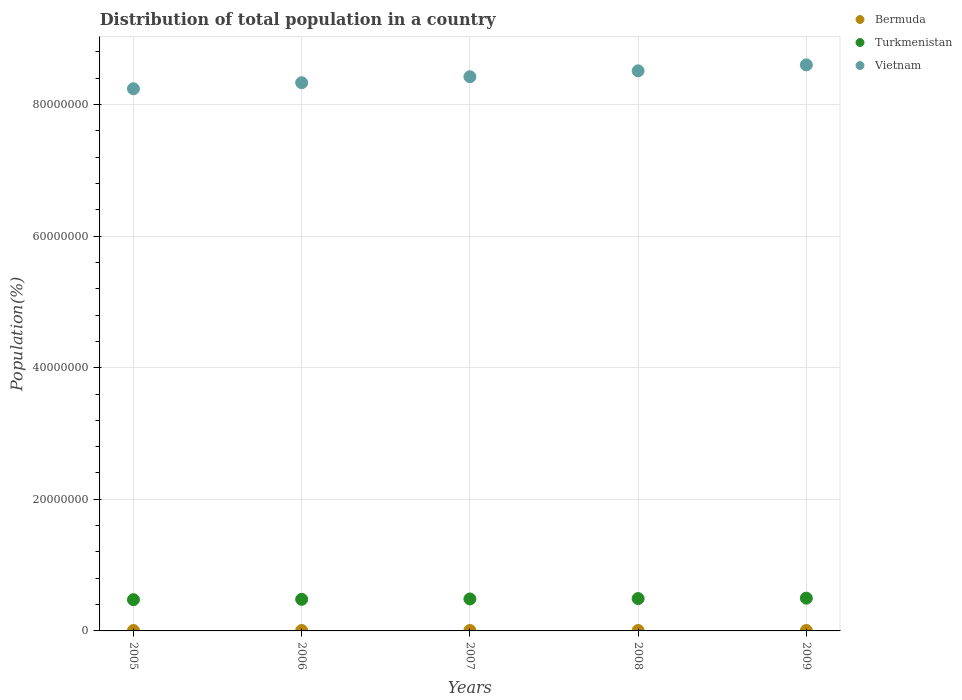What is the population of in Turkmenistan in 2008?
Your answer should be very brief. 4.92e+06. Across all years, what is the maximum population of in Vietnam?
Your answer should be very brief. 8.60e+07. Across all years, what is the minimum population of in Turkmenistan?
Ensure brevity in your answer.  4.75e+06. What is the total population of in Bermuda in the graph?
Your answer should be very brief. 3.24e+05. What is the difference between the population of in Turkmenistan in 2005 and that in 2006?
Your answer should be very brief. -5.38e+04. What is the difference between the population of in Vietnam in 2005 and the population of in Bermuda in 2009?
Provide a short and direct response. 8.23e+07. What is the average population of in Turkmenistan per year?
Make the answer very short. 4.86e+06. In the year 2008, what is the difference between the population of in Vietnam and population of in Bermuda?
Your answer should be compact. 8.51e+07. In how many years, is the population of in Bermuda greater than 80000000 %?
Provide a short and direct response. 0. What is the ratio of the population of in Turkmenistan in 2005 to that in 2006?
Offer a very short reply. 0.99. What is the difference between the highest and the second highest population of in Bermuda?
Provide a succinct answer. 363. What is the difference between the highest and the lowest population of in Bermuda?
Give a very brief answer. 1482. Is the sum of the population of in Bermuda in 2006 and 2009 greater than the maximum population of in Turkmenistan across all years?
Make the answer very short. No. Is it the case that in every year, the sum of the population of in Bermuda and population of in Turkmenistan  is greater than the population of in Vietnam?
Offer a terse response. No. Does the population of in Bermuda monotonically increase over the years?
Keep it short and to the point. Yes. Is the population of in Vietnam strictly less than the population of in Bermuda over the years?
Keep it short and to the point. No. How many years are there in the graph?
Your response must be concise. 5. Where does the legend appear in the graph?
Make the answer very short. Top right. How many legend labels are there?
Provide a succinct answer. 3. What is the title of the graph?
Provide a short and direct response. Distribution of total population in a country. What is the label or title of the Y-axis?
Your response must be concise. Population(%). What is the Population(%) of Bermuda in 2005?
Your response must be concise. 6.42e+04. What is the Population(%) in Turkmenistan in 2005?
Offer a very short reply. 4.75e+06. What is the Population(%) in Vietnam in 2005?
Offer a terse response. 8.24e+07. What is the Population(%) of Bermuda in 2006?
Give a very brief answer. 6.45e+04. What is the Population(%) of Turkmenistan in 2006?
Offer a terse response. 4.80e+06. What is the Population(%) of Vietnam in 2006?
Ensure brevity in your answer.  8.33e+07. What is the Population(%) in Bermuda in 2007?
Your answer should be compact. 6.49e+04. What is the Population(%) of Turkmenistan in 2007?
Your response must be concise. 4.86e+06. What is the Population(%) of Vietnam in 2007?
Make the answer very short. 8.42e+07. What is the Population(%) in Bermuda in 2008?
Offer a very short reply. 6.53e+04. What is the Population(%) of Turkmenistan in 2008?
Keep it short and to the point. 4.92e+06. What is the Population(%) of Vietnam in 2008?
Ensure brevity in your answer.  8.51e+07. What is the Population(%) of Bermuda in 2009?
Offer a very short reply. 6.56e+04. What is the Population(%) of Turkmenistan in 2009?
Your answer should be compact. 4.98e+06. What is the Population(%) of Vietnam in 2009?
Offer a terse response. 8.60e+07. Across all years, what is the maximum Population(%) of Bermuda?
Keep it short and to the point. 6.56e+04. Across all years, what is the maximum Population(%) of Turkmenistan?
Offer a terse response. 4.98e+06. Across all years, what is the maximum Population(%) of Vietnam?
Provide a short and direct response. 8.60e+07. Across all years, what is the minimum Population(%) of Bermuda?
Make the answer very short. 6.42e+04. Across all years, what is the minimum Population(%) of Turkmenistan?
Keep it short and to the point. 4.75e+06. Across all years, what is the minimum Population(%) of Vietnam?
Keep it short and to the point. 8.24e+07. What is the total Population(%) in Bermuda in the graph?
Your answer should be very brief. 3.24e+05. What is the total Population(%) in Turkmenistan in the graph?
Your response must be concise. 2.43e+07. What is the total Population(%) of Vietnam in the graph?
Give a very brief answer. 4.21e+08. What is the difference between the Population(%) of Bermuda in 2005 and that in 2006?
Keep it short and to the point. -369. What is the difference between the Population(%) in Turkmenistan in 2005 and that in 2006?
Make the answer very short. -5.38e+04. What is the difference between the Population(%) of Vietnam in 2005 and that in 2006?
Offer a very short reply. -9.19e+05. What is the difference between the Population(%) in Bermuda in 2005 and that in 2007?
Ensure brevity in your answer.  -734. What is the difference between the Population(%) in Turkmenistan in 2005 and that in 2007?
Offer a terse response. -1.10e+05. What is the difference between the Population(%) of Vietnam in 2005 and that in 2007?
Ensure brevity in your answer.  -1.83e+06. What is the difference between the Population(%) of Bermuda in 2005 and that in 2008?
Offer a terse response. -1119. What is the difference between the Population(%) in Turkmenistan in 2005 and that in 2008?
Your answer should be very brief. -1.70e+05. What is the difference between the Population(%) of Vietnam in 2005 and that in 2008?
Offer a terse response. -2.73e+06. What is the difference between the Population(%) in Bermuda in 2005 and that in 2009?
Make the answer very short. -1482. What is the difference between the Population(%) of Turkmenistan in 2005 and that in 2009?
Keep it short and to the point. -2.31e+05. What is the difference between the Population(%) in Vietnam in 2005 and that in 2009?
Ensure brevity in your answer.  -3.63e+06. What is the difference between the Population(%) of Bermuda in 2006 and that in 2007?
Make the answer very short. -365. What is the difference between the Population(%) in Turkmenistan in 2006 and that in 2007?
Keep it short and to the point. -5.66e+04. What is the difference between the Population(%) in Vietnam in 2006 and that in 2007?
Offer a terse response. -9.07e+05. What is the difference between the Population(%) in Bermuda in 2006 and that in 2008?
Offer a very short reply. -750. What is the difference between the Population(%) in Turkmenistan in 2006 and that in 2008?
Your answer should be very brief. -1.16e+05. What is the difference between the Population(%) in Vietnam in 2006 and that in 2008?
Ensure brevity in your answer.  -1.81e+06. What is the difference between the Population(%) in Bermuda in 2006 and that in 2009?
Give a very brief answer. -1113. What is the difference between the Population(%) in Turkmenistan in 2006 and that in 2009?
Make the answer very short. -1.77e+05. What is the difference between the Population(%) in Vietnam in 2006 and that in 2009?
Your answer should be very brief. -2.71e+06. What is the difference between the Population(%) of Bermuda in 2007 and that in 2008?
Your response must be concise. -385. What is the difference between the Population(%) in Turkmenistan in 2007 and that in 2008?
Your response must be concise. -5.93e+04. What is the difference between the Population(%) in Vietnam in 2007 and that in 2008?
Offer a very short reply. -9.00e+05. What is the difference between the Population(%) of Bermuda in 2007 and that in 2009?
Keep it short and to the point. -748. What is the difference between the Population(%) in Turkmenistan in 2007 and that in 2009?
Make the answer very short. -1.21e+05. What is the difference between the Population(%) of Vietnam in 2007 and that in 2009?
Your response must be concise. -1.81e+06. What is the difference between the Population(%) in Bermuda in 2008 and that in 2009?
Provide a succinct answer. -363. What is the difference between the Population(%) of Turkmenistan in 2008 and that in 2009?
Your answer should be compact. -6.14e+04. What is the difference between the Population(%) in Vietnam in 2008 and that in 2009?
Your response must be concise. -9.06e+05. What is the difference between the Population(%) of Bermuda in 2005 and the Population(%) of Turkmenistan in 2006?
Offer a very short reply. -4.74e+06. What is the difference between the Population(%) of Bermuda in 2005 and the Population(%) of Vietnam in 2006?
Your answer should be compact. -8.32e+07. What is the difference between the Population(%) in Turkmenistan in 2005 and the Population(%) in Vietnam in 2006?
Make the answer very short. -7.86e+07. What is the difference between the Population(%) of Bermuda in 2005 and the Population(%) of Turkmenistan in 2007?
Give a very brief answer. -4.79e+06. What is the difference between the Population(%) of Bermuda in 2005 and the Population(%) of Vietnam in 2007?
Offer a very short reply. -8.42e+07. What is the difference between the Population(%) in Turkmenistan in 2005 and the Population(%) in Vietnam in 2007?
Make the answer very short. -7.95e+07. What is the difference between the Population(%) of Bermuda in 2005 and the Population(%) of Turkmenistan in 2008?
Offer a terse response. -4.85e+06. What is the difference between the Population(%) of Bermuda in 2005 and the Population(%) of Vietnam in 2008?
Offer a very short reply. -8.51e+07. What is the difference between the Population(%) in Turkmenistan in 2005 and the Population(%) in Vietnam in 2008?
Your answer should be compact. -8.04e+07. What is the difference between the Population(%) of Bermuda in 2005 and the Population(%) of Turkmenistan in 2009?
Ensure brevity in your answer.  -4.91e+06. What is the difference between the Population(%) of Bermuda in 2005 and the Population(%) of Vietnam in 2009?
Offer a very short reply. -8.60e+07. What is the difference between the Population(%) of Turkmenistan in 2005 and the Population(%) of Vietnam in 2009?
Offer a very short reply. -8.13e+07. What is the difference between the Population(%) of Bermuda in 2006 and the Population(%) of Turkmenistan in 2007?
Provide a succinct answer. -4.79e+06. What is the difference between the Population(%) in Bermuda in 2006 and the Population(%) in Vietnam in 2007?
Your response must be concise. -8.42e+07. What is the difference between the Population(%) in Turkmenistan in 2006 and the Population(%) in Vietnam in 2007?
Offer a very short reply. -7.94e+07. What is the difference between the Population(%) in Bermuda in 2006 and the Population(%) in Turkmenistan in 2008?
Your answer should be compact. -4.85e+06. What is the difference between the Population(%) of Bermuda in 2006 and the Population(%) of Vietnam in 2008?
Keep it short and to the point. -8.51e+07. What is the difference between the Population(%) in Turkmenistan in 2006 and the Population(%) in Vietnam in 2008?
Keep it short and to the point. -8.03e+07. What is the difference between the Population(%) of Bermuda in 2006 and the Population(%) of Turkmenistan in 2009?
Your answer should be very brief. -4.91e+06. What is the difference between the Population(%) in Bermuda in 2006 and the Population(%) in Vietnam in 2009?
Give a very brief answer. -8.60e+07. What is the difference between the Population(%) of Turkmenistan in 2006 and the Population(%) of Vietnam in 2009?
Your response must be concise. -8.12e+07. What is the difference between the Population(%) of Bermuda in 2007 and the Population(%) of Turkmenistan in 2008?
Keep it short and to the point. -4.85e+06. What is the difference between the Population(%) of Bermuda in 2007 and the Population(%) of Vietnam in 2008?
Your answer should be compact. -8.51e+07. What is the difference between the Population(%) in Turkmenistan in 2007 and the Population(%) in Vietnam in 2008?
Provide a short and direct response. -8.03e+07. What is the difference between the Population(%) of Bermuda in 2007 and the Population(%) of Turkmenistan in 2009?
Your response must be concise. -4.91e+06. What is the difference between the Population(%) in Bermuda in 2007 and the Population(%) in Vietnam in 2009?
Make the answer very short. -8.60e+07. What is the difference between the Population(%) of Turkmenistan in 2007 and the Population(%) of Vietnam in 2009?
Provide a short and direct response. -8.12e+07. What is the difference between the Population(%) of Bermuda in 2008 and the Population(%) of Turkmenistan in 2009?
Offer a very short reply. -4.91e+06. What is the difference between the Population(%) of Bermuda in 2008 and the Population(%) of Vietnam in 2009?
Your answer should be very brief. -8.60e+07. What is the difference between the Population(%) in Turkmenistan in 2008 and the Population(%) in Vietnam in 2009?
Provide a succinct answer. -8.11e+07. What is the average Population(%) of Bermuda per year?
Give a very brief answer. 6.49e+04. What is the average Population(%) in Turkmenistan per year?
Ensure brevity in your answer.  4.86e+06. What is the average Population(%) in Vietnam per year?
Your answer should be compact. 8.42e+07. In the year 2005, what is the difference between the Population(%) of Bermuda and Population(%) of Turkmenistan?
Make the answer very short. -4.68e+06. In the year 2005, what is the difference between the Population(%) in Bermuda and Population(%) in Vietnam?
Make the answer very short. -8.23e+07. In the year 2005, what is the difference between the Population(%) of Turkmenistan and Population(%) of Vietnam?
Make the answer very short. -7.76e+07. In the year 2006, what is the difference between the Population(%) of Bermuda and Population(%) of Turkmenistan?
Offer a very short reply. -4.74e+06. In the year 2006, what is the difference between the Population(%) of Bermuda and Population(%) of Vietnam?
Your answer should be very brief. -8.32e+07. In the year 2006, what is the difference between the Population(%) in Turkmenistan and Population(%) in Vietnam?
Offer a very short reply. -7.85e+07. In the year 2007, what is the difference between the Population(%) in Bermuda and Population(%) in Turkmenistan?
Make the answer very short. -4.79e+06. In the year 2007, what is the difference between the Population(%) of Bermuda and Population(%) of Vietnam?
Ensure brevity in your answer.  -8.42e+07. In the year 2007, what is the difference between the Population(%) of Turkmenistan and Population(%) of Vietnam?
Keep it short and to the point. -7.94e+07. In the year 2008, what is the difference between the Population(%) in Bermuda and Population(%) in Turkmenistan?
Keep it short and to the point. -4.85e+06. In the year 2008, what is the difference between the Population(%) in Bermuda and Population(%) in Vietnam?
Provide a succinct answer. -8.51e+07. In the year 2008, what is the difference between the Population(%) in Turkmenistan and Population(%) in Vietnam?
Keep it short and to the point. -8.02e+07. In the year 2009, what is the difference between the Population(%) in Bermuda and Population(%) in Turkmenistan?
Give a very brief answer. -4.91e+06. In the year 2009, what is the difference between the Population(%) of Bermuda and Population(%) of Vietnam?
Your answer should be very brief. -8.60e+07. In the year 2009, what is the difference between the Population(%) in Turkmenistan and Population(%) in Vietnam?
Your response must be concise. -8.10e+07. What is the ratio of the Population(%) in Turkmenistan in 2005 to that in 2006?
Make the answer very short. 0.99. What is the ratio of the Population(%) of Vietnam in 2005 to that in 2006?
Offer a very short reply. 0.99. What is the ratio of the Population(%) in Bermuda in 2005 to that in 2007?
Give a very brief answer. 0.99. What is the ratio of the Population(%) of Turkmenistan in 2005 to that in 2007?
Make the answer very short. 0.98. What is the ratio of the Population(%) of Vietnam in 2005 to that in 2007?
Ensure brevity in your answer.  0.98. What is the ratio of the Population(%) in Bermuda in 2005 to that in 2008?
Your answer should be compact. 0.98. What is the ratio of the Population(%) in Turkmenistan in 2005 to that in 2008?
Keep it short and to the point. 0.97. What is the ratio of the Population(%) in Bermuda in 2005 to that in 2009?
Give a very brief answer. 0.98. What is the ratio of the Population(%) in Turkmenistan in 2005 to that in 2009?
Provide a succinct answer. 0.95. What is the ratio of the Population(%) of Vietnam in 2005 to that in 2009?
Your answer should be very brief. 0.96. What is the ratio of the Population(%) of Turkmenistan in 2006 to that in 2007?
Offer a very short reply. 0.99. What is the ratio of the Population(%) in Bermuda in 2006 to that in 2008?
Ensure brevity in your answer.  0.99. What is the ratio of the Population(%) of Turkmenistan in 2006 to that in 2008?
Offer a terse response. 0.98. What is the ratio of the Population(%) of Vietnam in 2006 to that in 2008?
Offer a terse response. 0.98. What is the ratio of the Population(%) of Bermuda in 2006 to that in 2009?
Give a very brief answer. 0.98. What is the ratio of the Population(%) of Turkmenistan in 2006 to that in 2009?
Provide a short and direct response. 0.96. What is the ratio of the Population(%) in Vietnam in 2006 to that in 2009?
Offer a terse response. 0.97. What is the ratio of the Population(%) in Turkmenistan in 2007 to that in 2008?
Keep it short and to the point. 0.99. What is the ratio of the Population(%) in Vietnam in 2007 to that in 2008?
Provide a short and direct response. 0.99. What is the ratio of the Population(%) in Bermuda in 2007 to that in 2009?
Provide a succinct answer. 0.99. What is the ratio of the Population(%) in Turkmenistan in 2007 to that in 2009?
Offer a very short reply. 0.98. What is the ratio of the Population(%) in Vietnam in 2007 to that in 2009?
Your answer should be compact. 0.98. What is the ratio of the Population(%) in Bermuda in 2008 to that in 2009?
Your answer should be very brief. 0.99. What is the ratio of the Population(%) of Turkmenistan in 2008 to that in 2009?
Keep it short and to the point. 0.99. What is the ratio of the Population(%) in Vietnam in 2008 to that in 2009?
Your answer should be very brief. 0.99. What is the difference between the highest and the second highest Population(%) of Bermuda?
Make the answer very short. 363. What is the difference between the highest and the second highest Population(%) of Turkmenistan?
Make the answer very short. 6.14e+04. What is the difference between the highest and the second highest Population(%) in Vietnam?
Offer a terse response. 9.06e+05. What is the difference between the highest and the lowest Population(%) in Bermuda?
Offer a very short reply. 1482. What is the difference between the highest and the lowest Population(%) in Turkmenistan?
Ensure brevity in your answer.  2.31e+05. What is the difference between the highest and the lowest Population(%) of Vietnam?
Your answer should be very brief. 3.63e+06. 